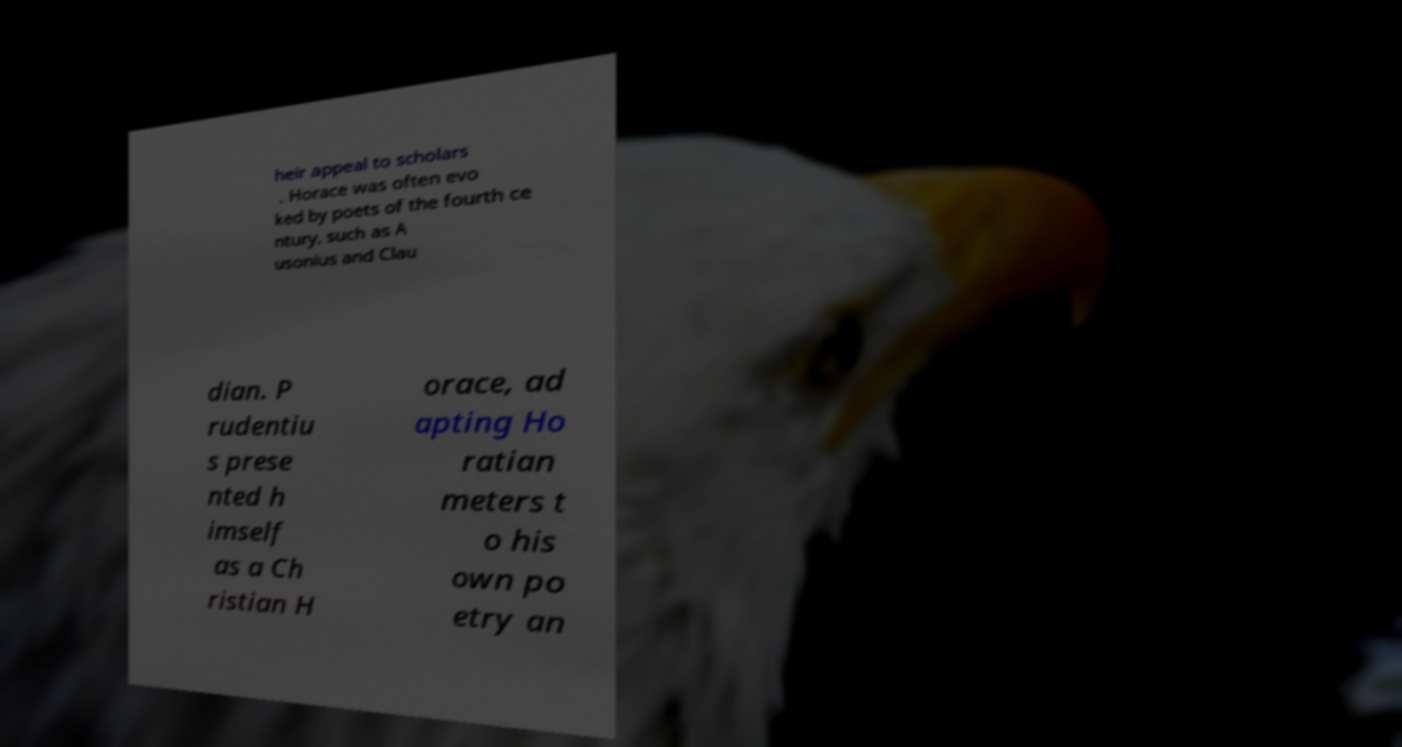What messages or text are displayed in this image? I need them in a readable, typed format. heir appeal to scholars . Horace was often evo ked by poets of the fourth ce ntury, such as A usonius and Clau dian. P rudentiu s prese nted h imself as a Ch ristian H orace, ad apting Ho ratian meters t o his own po etry an 